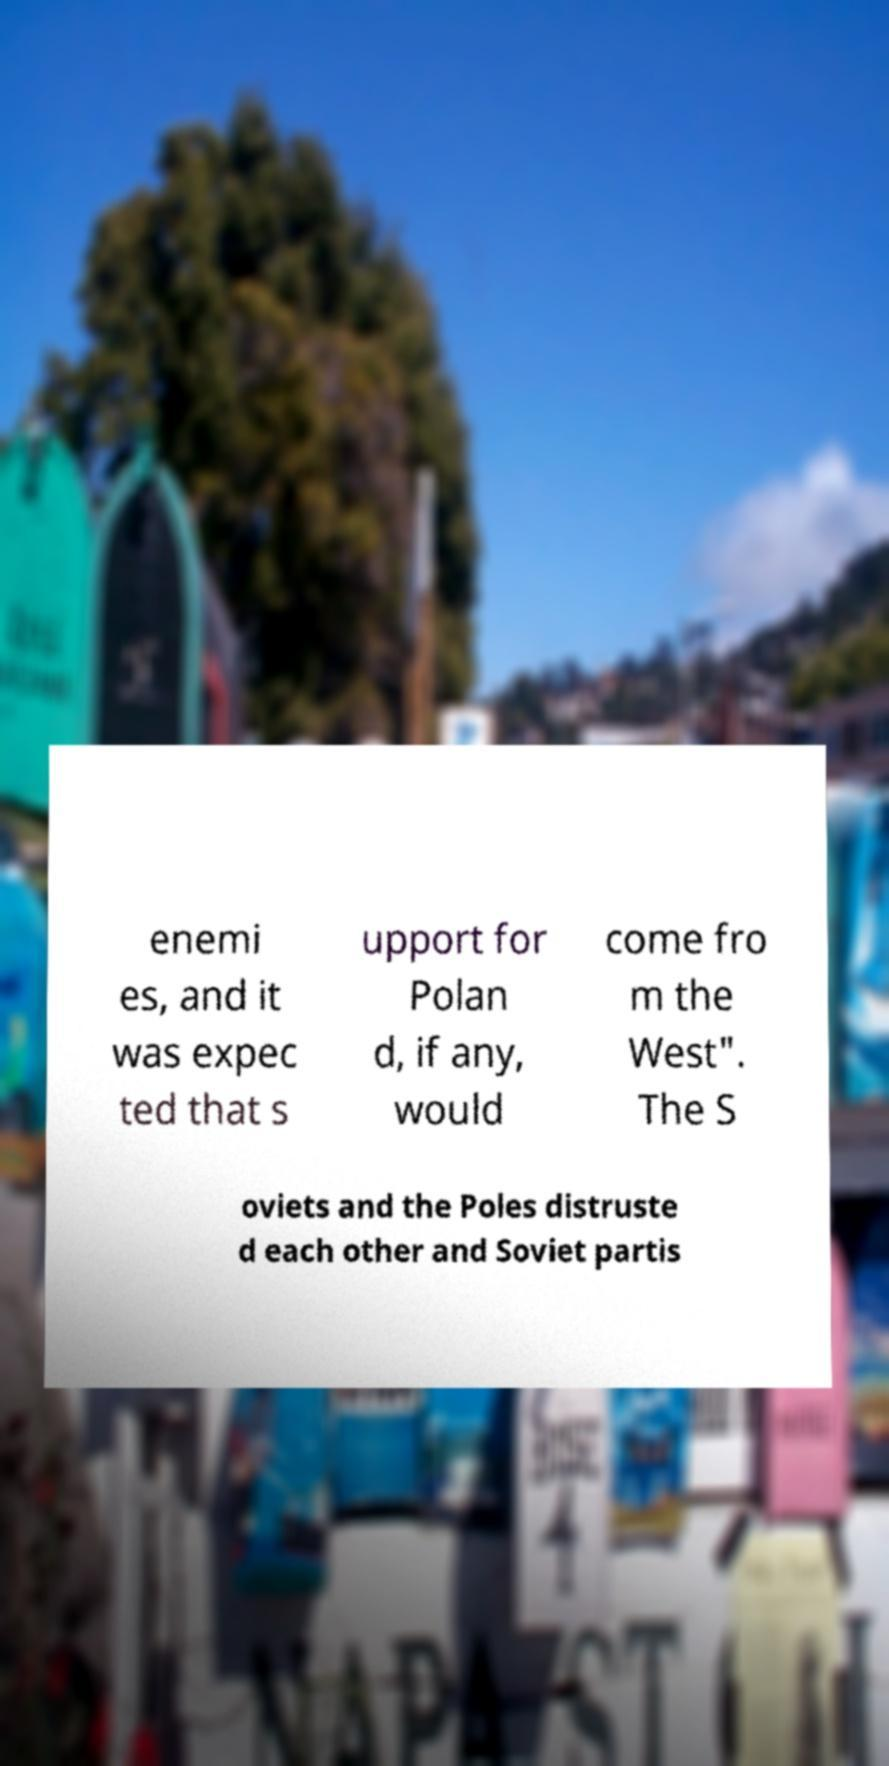Could you assist in decoding the text presented in this image and type it out clearly? enemi es, and it was expec ted that s upport for Polan d, if any, would come fro m the West". The S oviets and the Poles distruste d each other and Soviet partis 